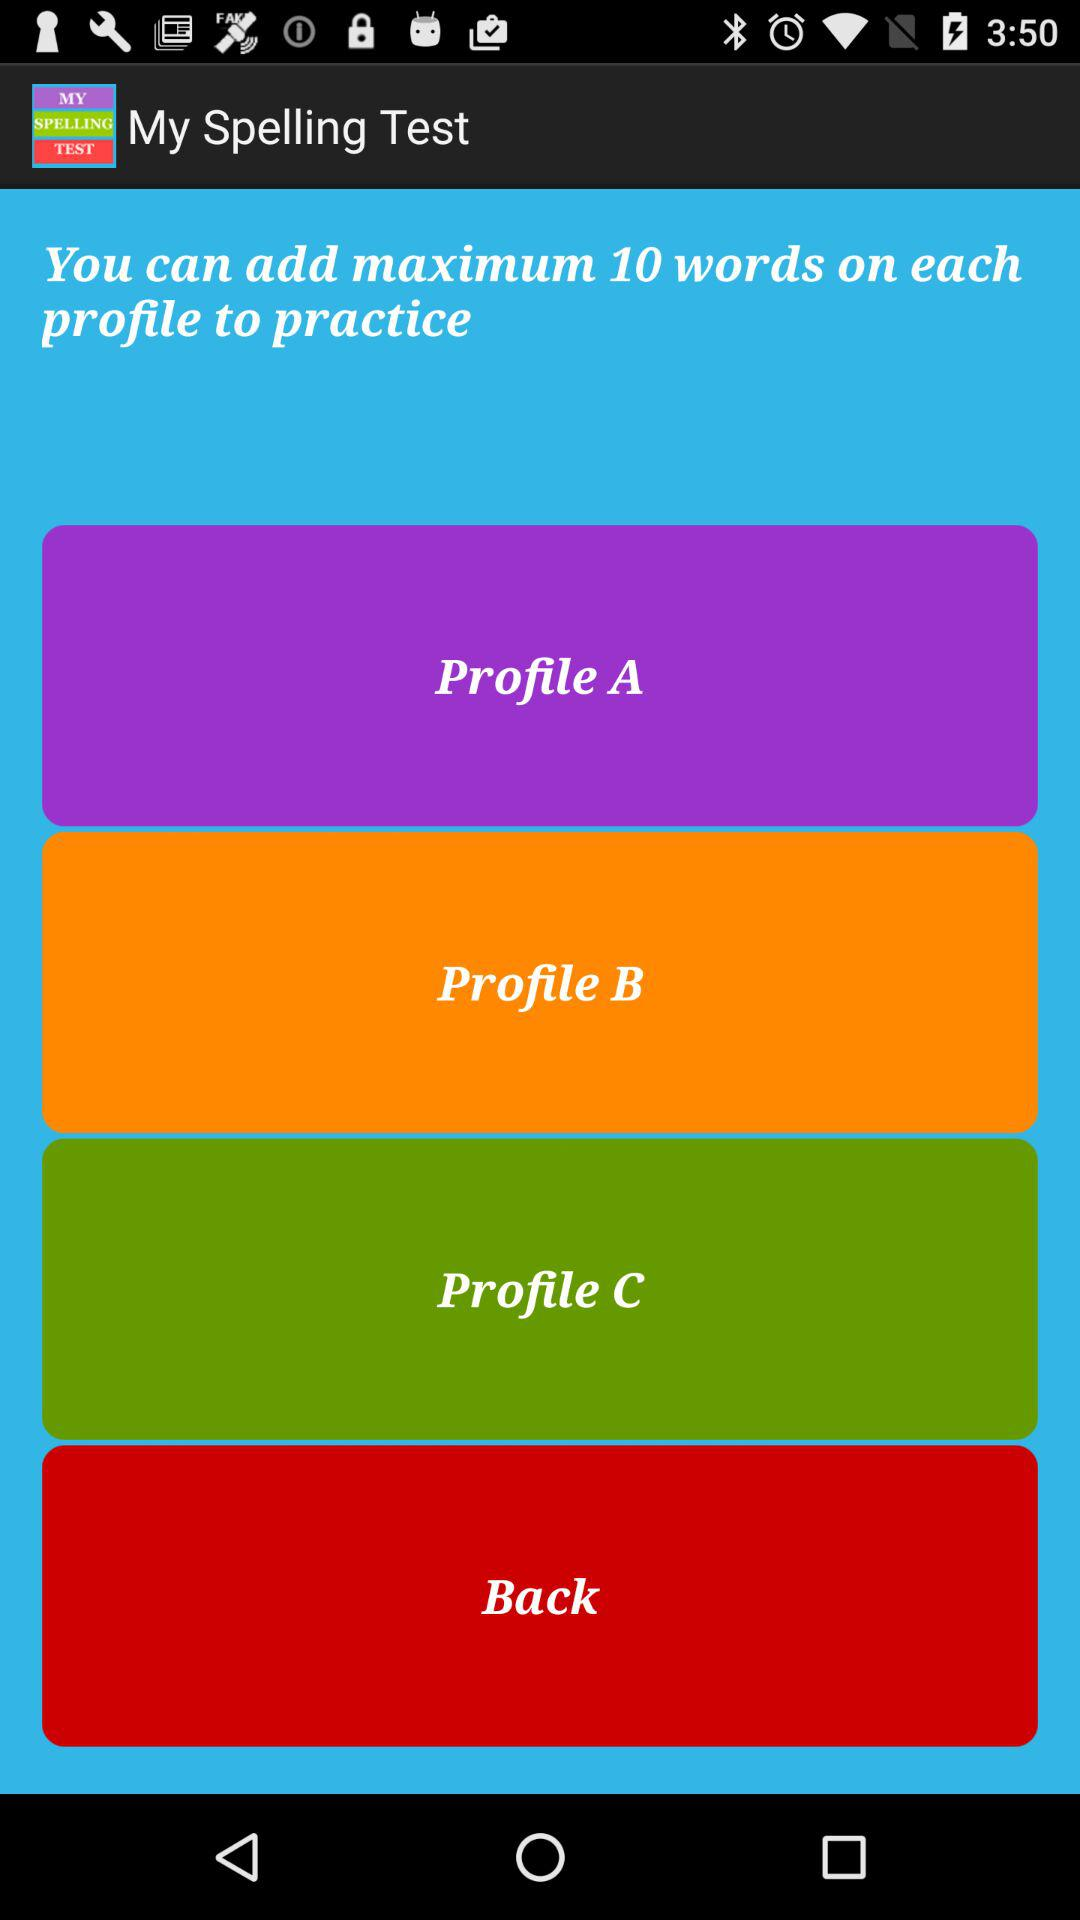How many words can we add to each profile? You can add a maximum of 10 to each profile. 